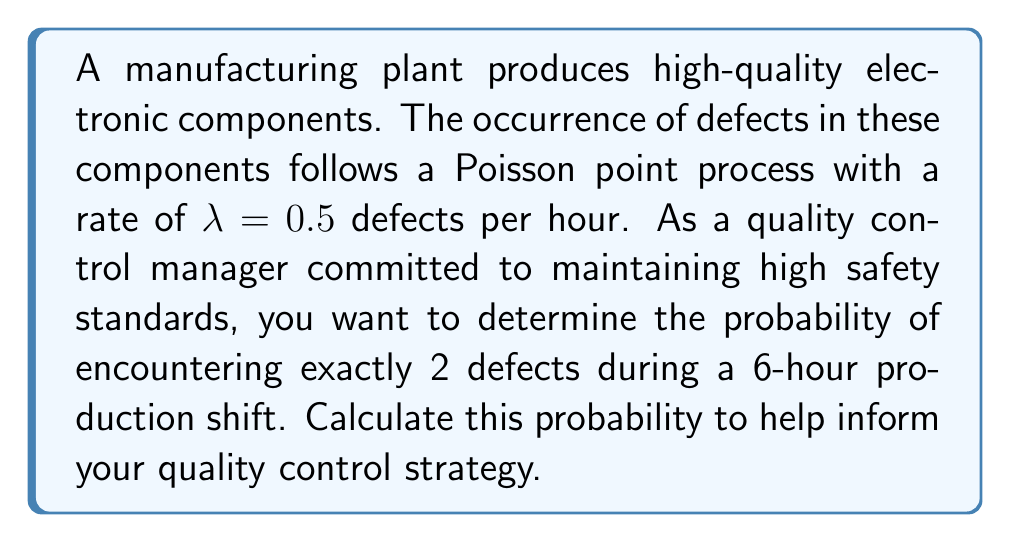Solve this math problem. To solve this problem, we'll use the Poisson distribution formula, which is appropriate for modeling the number of events in a fixed interval when those events follow a Poisson point process.

Step 1: Identify the parameters
- Rate ($\lambda$) = 0.5 defects per hour
- Time interval (t) = 6 hours
- Number of defects (k) = 2

Step 2: Calculate the average number of defects in the 6-hour period
$\mu = \lambda t = 0.5 \times 6 = 3$

Step 3: Apply the Poisson distribution formula
The probability of k events occurring in a Poisson process is given by:

$$P(X = k) = \frac{e^{-\mu} \mu^k}{k!}$$

Where:
- e is Euler's number (approximately 2.71828)
- $\mu$ is the average number of events in the interval
- k is the number of events we're interested in

Substituting our values:

$$P(X = 2) = \frac{e^{-3} 3^2}{2!}$$

Step 4: Calculate the result
$$P(X = 2) = \frac{e^{-3} \times 9}{2} \approx 0.2240$$

Therefore, the probability of encountering exactly 2 defects during a 6-hour production shift is approximately 0.2240 or 22.40%.
Answer: 0.2240 